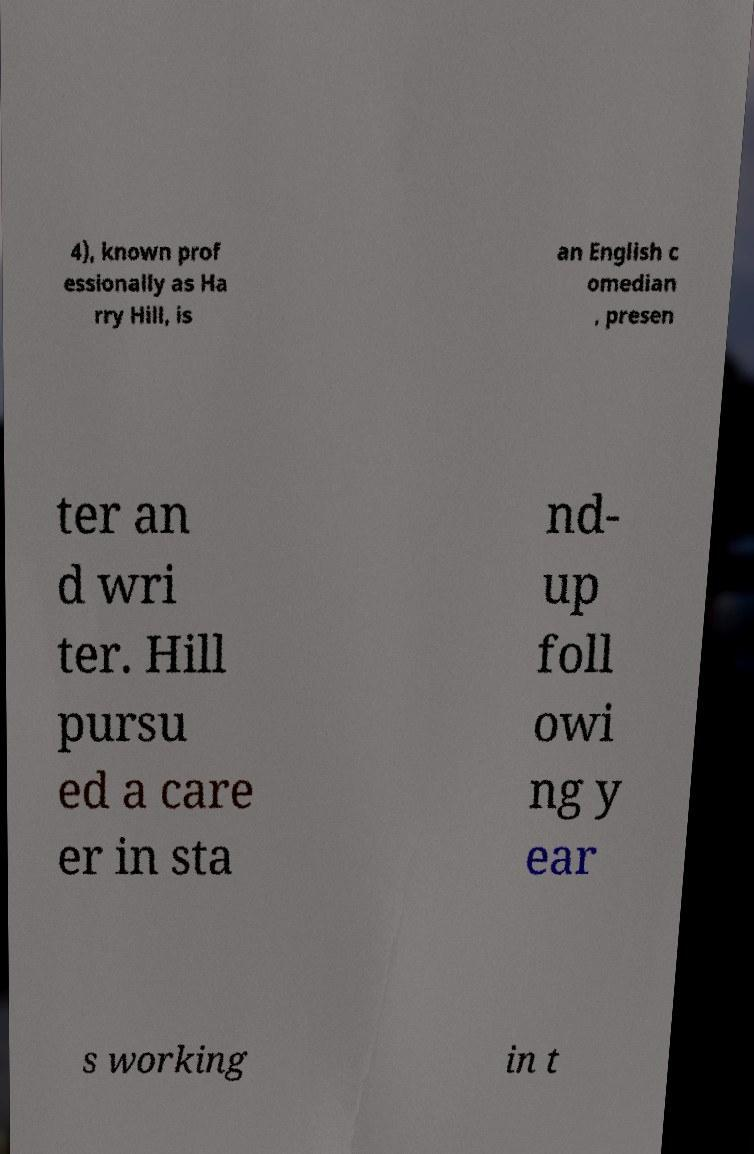Please read and relay the text visible in this image. What does it say? 4), known prof essionally as Ha rry Hill, is an English c omedian , presen ter an d wri ter. Hill pursu ed a care er in sta nd- up foll owi ng y ear s working in t 